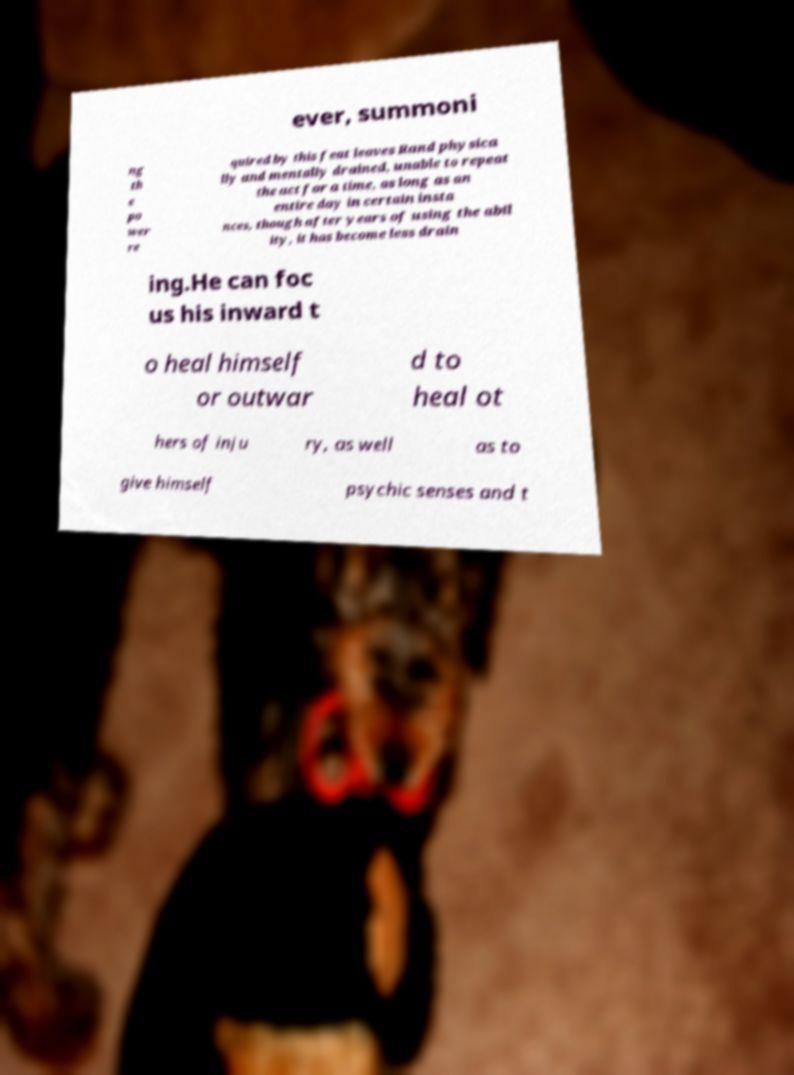Could you assist in decoding the text presented in this image and type it out clearly? ever, summoni ng th e po wer re quired by this feat leaves Rand physica lly and mentally drained, unable to repeat the act for a time, as long as an entire day in certain insta nces, though after years of using the abil ity, it has become less drain ing.He can foc us his inward t o heal himself or outwar d to heal ot hers of inju ry, as well as to give himself psychic senses and t 